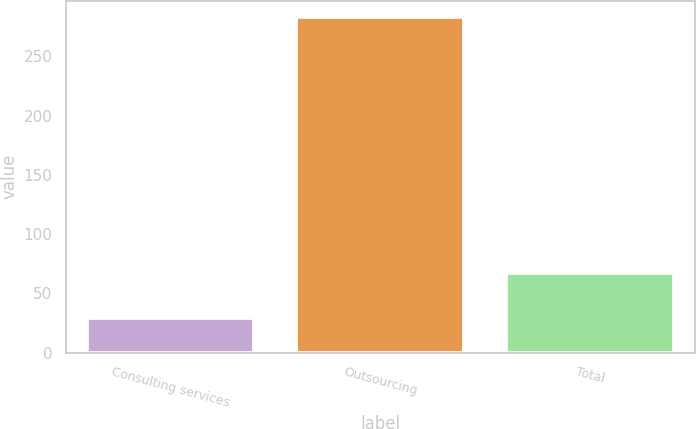<chart> <loc_0><loc_0><loc_500><loc_500><bar_chart><fcel>Consulting services<fcel>Outsourcing<fcel>Total<nl><fcel>29<fcel>283<fcel>67<nl></chart> 